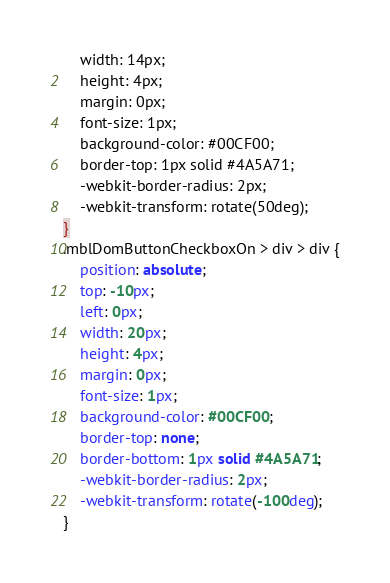<code> <loc_0><loc_0><loc_500><loc_500><_CSS_>	width: 14px;
	height: 4px;
	margin: 0px;
	font-size: 1px;
	background-color: #00CF00;
	border-top: 1px solid #4A5A71;
	-webkit-border-radius: 2px;
	-webkit-transform: rotate(50deg);
}
.mblDomButtonCheckboxOn > div > div {
	position: absolute;
	top: -10px;
	left: 0px;
	width: 20px;
	height: 4px;
	margin: 0px;
	font-size: 1px;
	background-color: #00CF00;
	border-top: none;
	border-bottom: 1px solid #4A5A71;
	-webkit-border-radius: 2px;
	-webkit-transform: rotate(-100deg);
}
</code> 